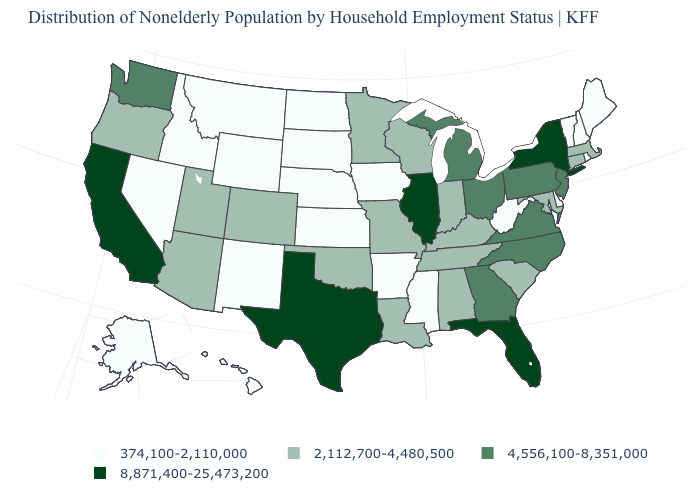Is the legend a continuous bar?
Quick response, please. No. Which states have the lowest value in the MidWest?
Concise answer only. Iowa, Kansas, Nebraska, North Dakota, South Dakota. What is the value of New Hampshire?
Answer briefly. 374,100-2,110,000. How many symbols are there in the legend?
Give a very brief answer. 4. What is the value of Nebraska?
Quick response, please. 374,100-2,110,000. Name the states that have a value in the range 8,871,400-25,473,200?
Short answer required. California, Florida, Illinois, New York, Texas. Name the states that have a value in the range 374,100-2,110,000?
Answer briefly. Alaska, Arkansas, Delaware, Hawaii, Idaho, Iowa, Kansas, Maine, Mississippi, Montana, Nebraska, Nevada, New Hampshire, New Mexico, North Dakota, Rhode Island, South Dakota, Vermont, West Virginia, Wyoming. What is the value of North Dakota?
Concise answer only. 374,100-2,110,000. Does Kentucky have the highest value in the USA?
Concise answer only. No. Is the legend a continuous bar?
Write a very short answer. No. What is the value of Illinois?
Answer briefly. 8,871,400-25,473,200. Among the states that border New York , which have the highest value?
Write a very short answer. New Jersey, Pennsylvania. Among the states that border West Virginia , which have the highest value?
Answer briefly. Ohio, Pennsylvania, Virginia. Among the states that border Nebraska , does Kansas have the lowest value?
Quick response, please. Yes. 